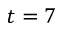Convert formula to latex. <formula><loc_0><loc_0><loc_500><loc_500>t = 7</formula> 